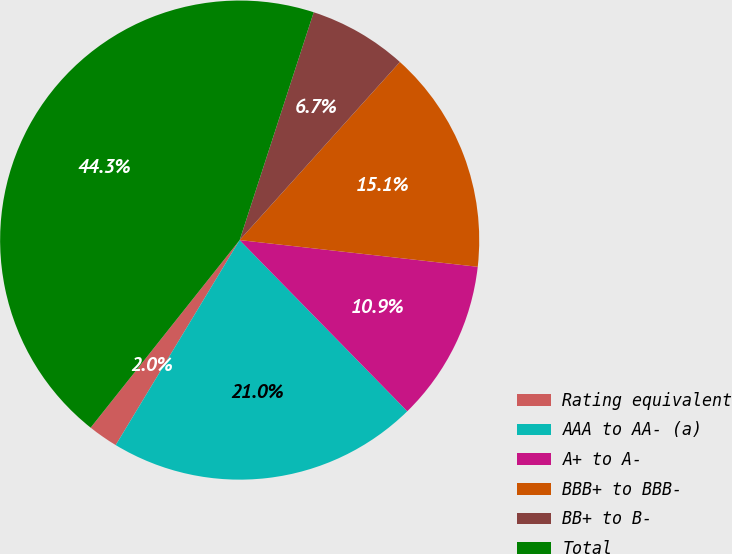Convert chart. <chart><loc_0><loc_0><loc_500><loc_500><pie_chart><fcel>Rating equivalent<fcel>AAA to AA- (a)<fcel>A+ to A-<fcel>BBB+ to BBB-<fcel>BB+ to B-<fcel>Total<nl><fcel>2.03%<fcel>20.99%<fcel>10.89%<fcel>15.12%<fcel>6.66%<fcel>44.32%<nl></chart> 